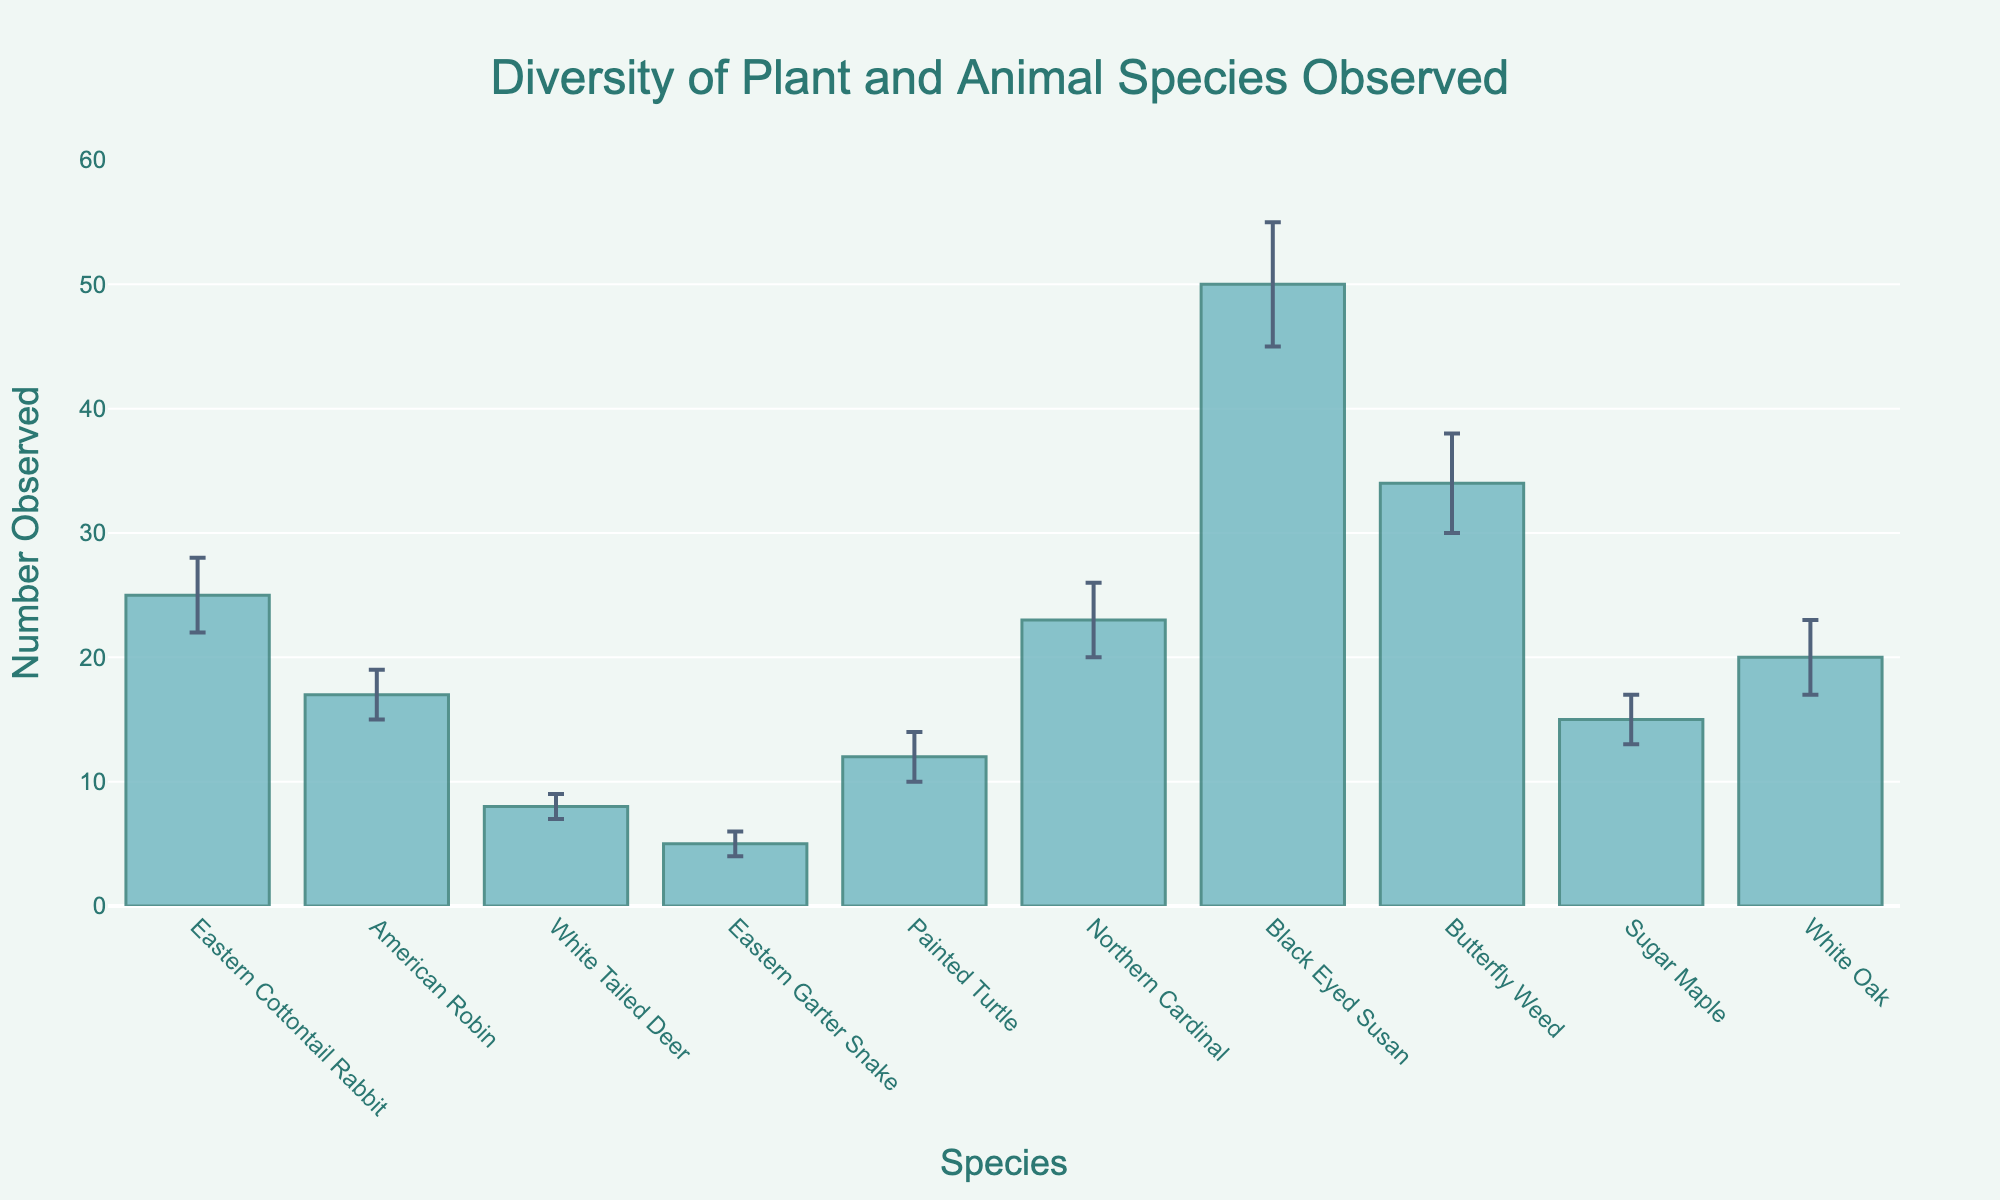What's the title of the chart? The title can be found at the top of the chart. It is typically in a larger font size and highlights what the chart is about.
Answer: Diversity of Plant and Animal Species Observed Which species was observed the most? Look for the tallest bar in the chart, which represents the species with the highest number of observations.
Answer: Black Eyed Susan Which species was observed with the most error range? Identify the bar with the largest error bars extending above and below the main bar.
Answer: Black Eyed Susan How many species have an observation count of more than 20? Count the number of bars exceeding the y-axis value of 20.
Answer: 3 What is the total number of Northern Cardinal and American Robin combined? Add the number of Northern Cardinal observations (23) to the number of American Robin observations (17).
Answer: 40 Which animal species had the fewest observations? Compare the heights of all bars representing animal species and identify the shortest one.
Answer: Eastern Garter Snake What is the average number of observations for plant species? Sum the number of observations for Black Eyed Susan (50), Butterfly Weed (34), Sugar Maple (15), and White Oak (20), then divide by 4.
Answer: 29.75 How much more were Northern Cardinal and Eastern Cottontail Rabbit observed compared to White-Tailed Deer? Subtract the number of White-Tailed Deer observations (8) from the sum of Northern Cardinal (23) and Eastern Cottontail Rabbit (25) observations.
Answer: 40 Which species' observation has the smallest error range? Identify the bar with the shortest error bars.
Answer: White-Tailed Deer What is the difference in observation count between Painted Turtle and Sugar Maple? Subtract the number of Sugar Maple observations (15) from the Painted Turtle observations (12).
Answer: -3 